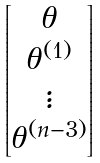Convert formula to latex. <formula><loc_0><loc_0><loc_500><loc_500>\begin{bmatrix} \theta \\ \theta ^ { ( 1 ) } \\ \vdots \\ \theta ^ { ( n - 3 ) } \end{bmatrix}</formula> 